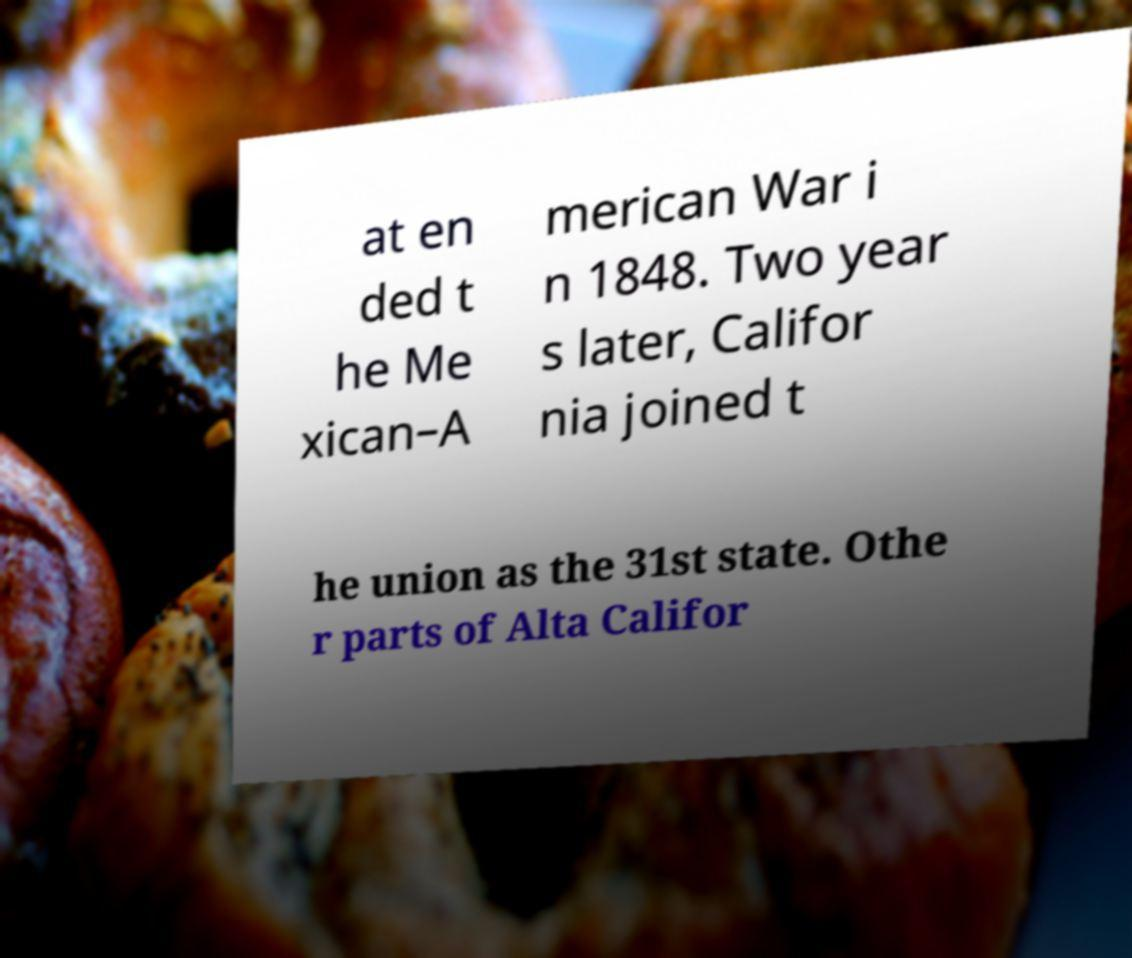For documentation purposes, I need the text within this image transcribed. Could you provide that? at en ded t he Me xican–A merican War i n 1848. Two year s later, Califor nia joined t he union as the 31st state. Othe r parts of Alta Califor 